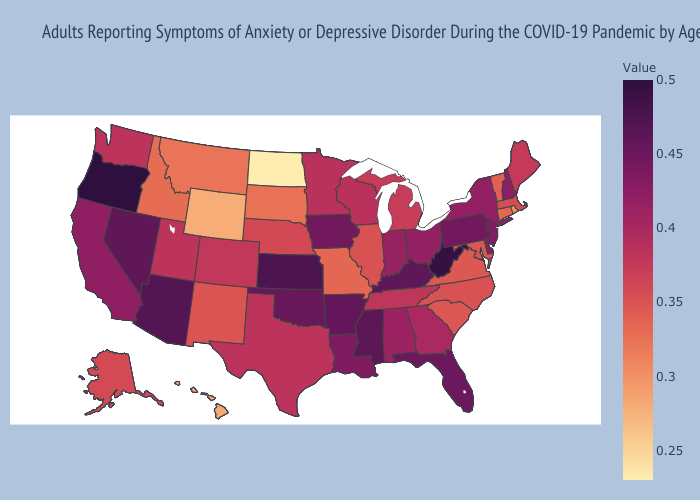Among the states that border Oregon , which have the lowest value?
Concise answer only. Idaho. Among the states that border New Mexico , does Utah have the highest value?
Write a very short answer. No. Does Iowa have a higher value than Kansas?
Keep it brief. No. Does Ohio have the lowest value in the MidWest?
Be succinct. No. 